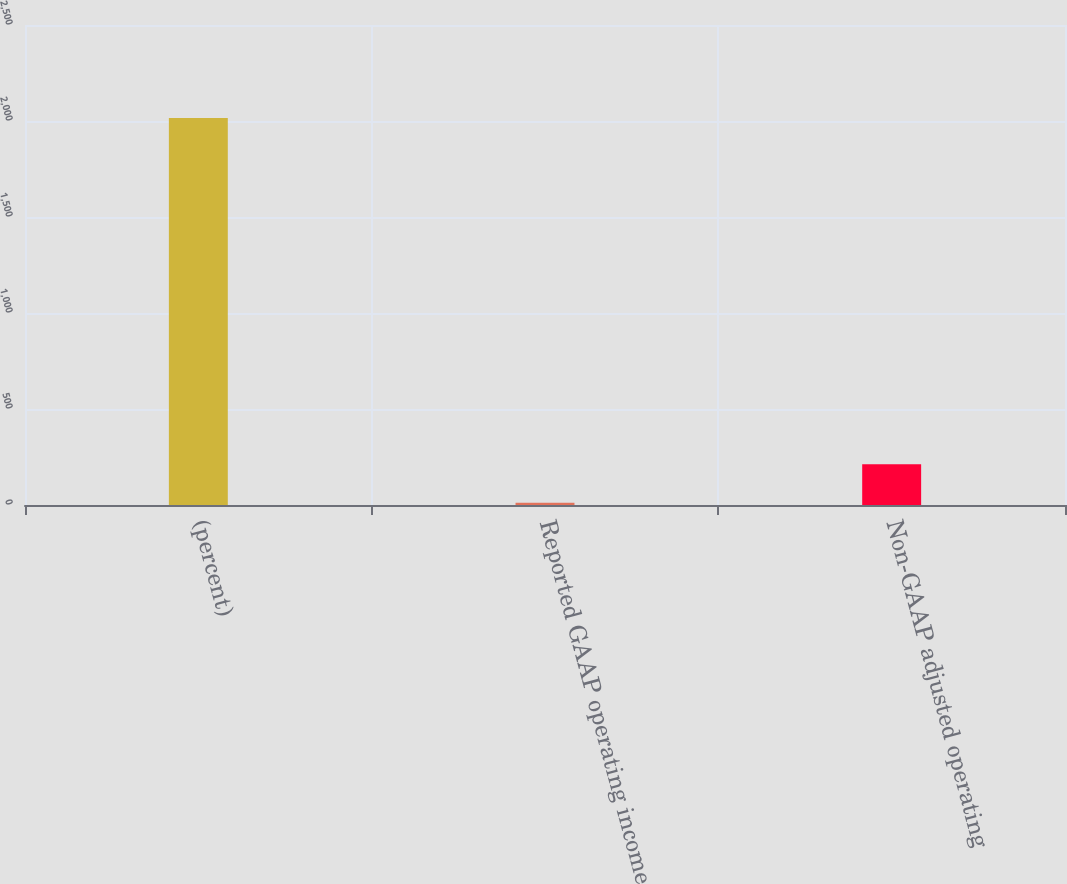Convert chart. <chart><loc_0><loc_0><loc_500><loc_500><bar_chart><fcel>(percent)<fcel>Reported GAAP operating income<fcel>Non-GAAP adjusted operating<nl><fcel>2015<fcel>11.5<fcel>211.85<nl></chart> 